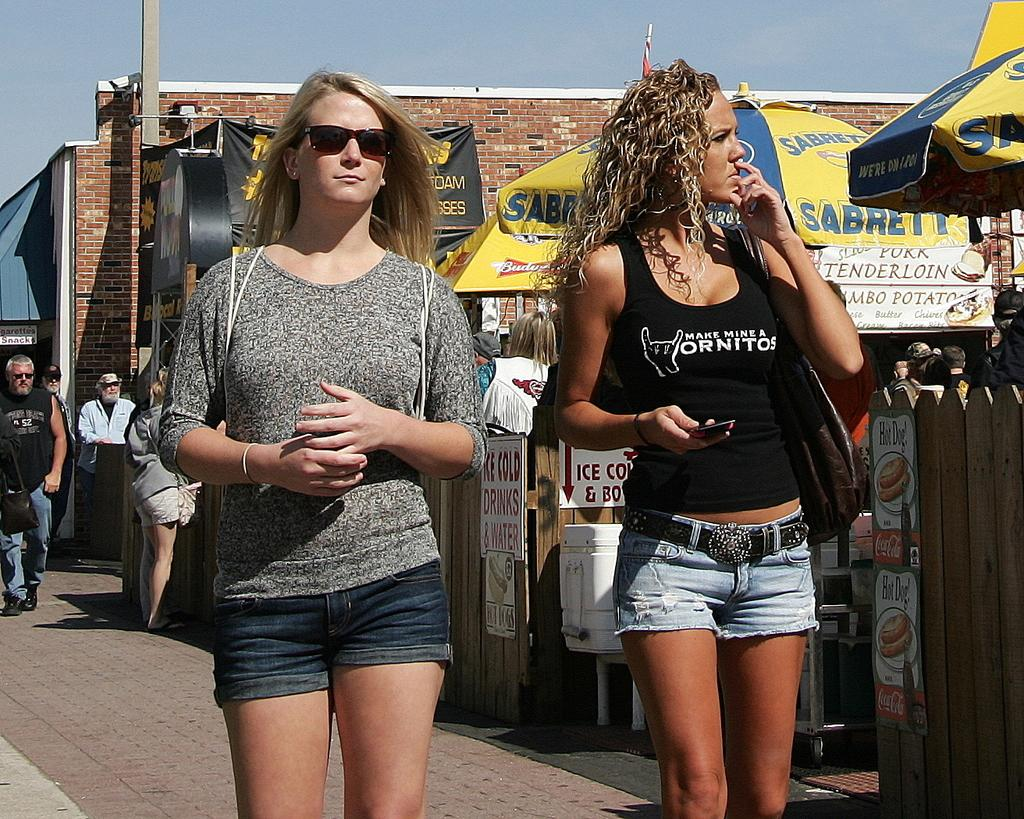How many women are present in the image? There are two women standing in the image. What objects are being used by the women in the image? There are umbrellas in the image. What type of establishment can be seen in the background? There are stores in the image. Can you describe the people behind the two women? There are other people behind the two women in the image. What type of boats can be seen in the scene? There are no boats present in the image; it features two women with umbrellas and stores in the background. What level of experience does the beginner have in the image? There is no indication of any beginner or their experience in the image. 